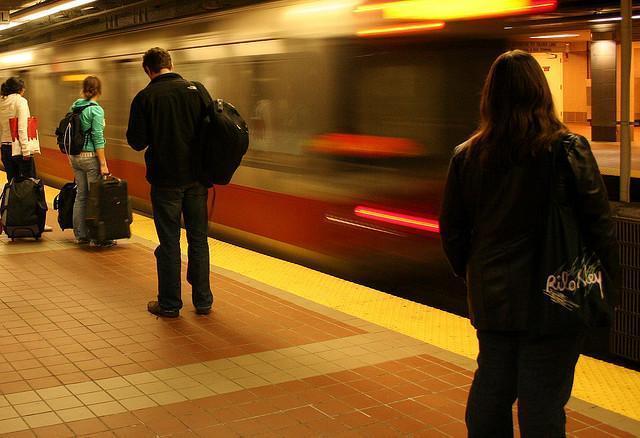How many of the passengers waiting for the train have at least one bag with them?
Give a very brief answer. 4. How many people are visible?
Give a very brief answer. 4. How many backpacks are there?
Give a very brief answer. 2. How many suitcases are in the photo?
Give a very brief answer. 2. How many pieces of pizza are left?
Give a very brief answer. 0. 